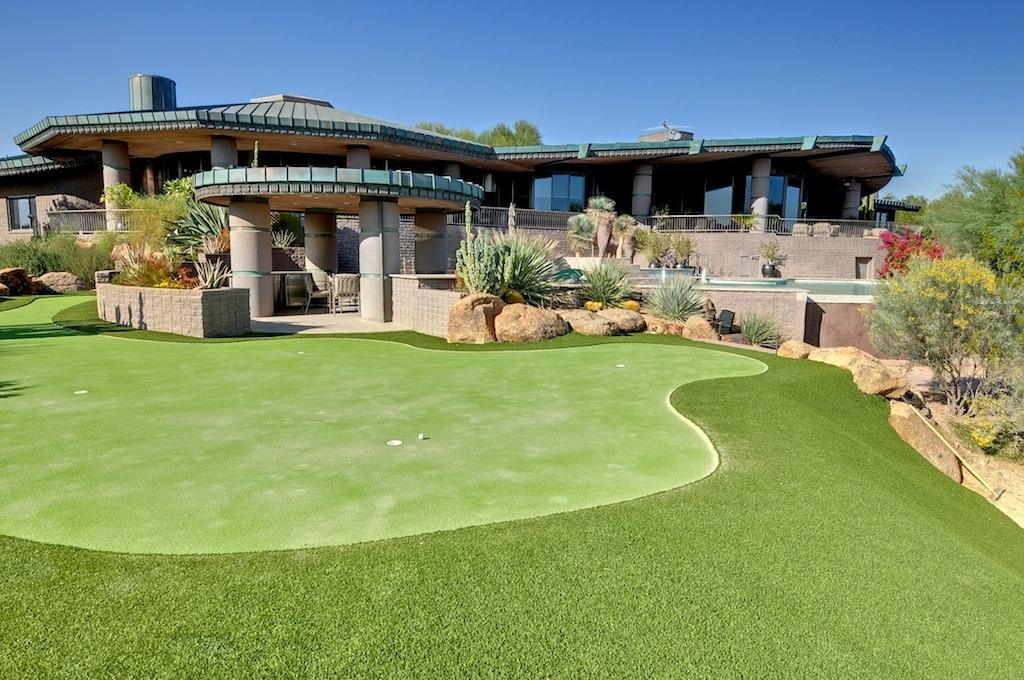What type of vegetation can be seen in the image? There are plants and trees in the image. What type of structures are present in the image? There are houses, pillars, walls, and railings in the image. What type of seating is visible in the image? There are chairs in the image. What type of material is present in the image? There are stones and glass objects in the image. What type of ground cover is visible in the image? There is grass in the image. What is visible at the top of the image? The sky is visible at the top of the image. What type of crime is being committed in the image? There is no indication of any crime being committed in the image. What type of vest is being worn by the person in the image? There are no people or vests present in the image. 